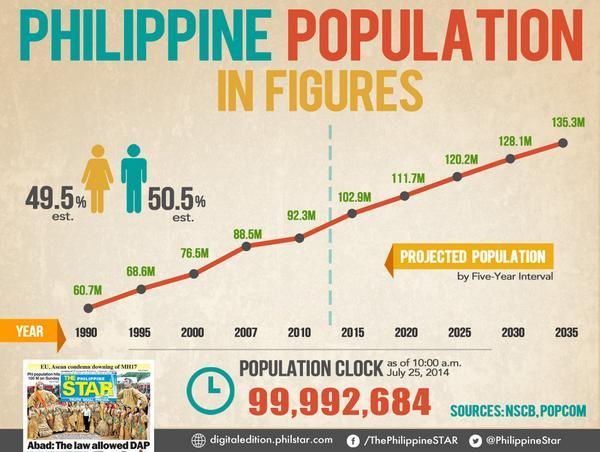List a handful of essential elements in this visual. In the year 2014, it is estimated that approximately 50.5% of the population in the Philippines was comprised of men. In 2000, the population of the Philippines was approximately 76.5 million. According to estimates, the population of women in the Philippines in 2014 was approximately 49.5%. According to projections, the population of the Philippines is expected to reach 128.1 million in 2030. 